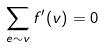<formula> <loc_0><loc_0><loc_500><loc_500>\sum _ { e \sim v } f ^ { \prime } ( v ) = 0</formula> 